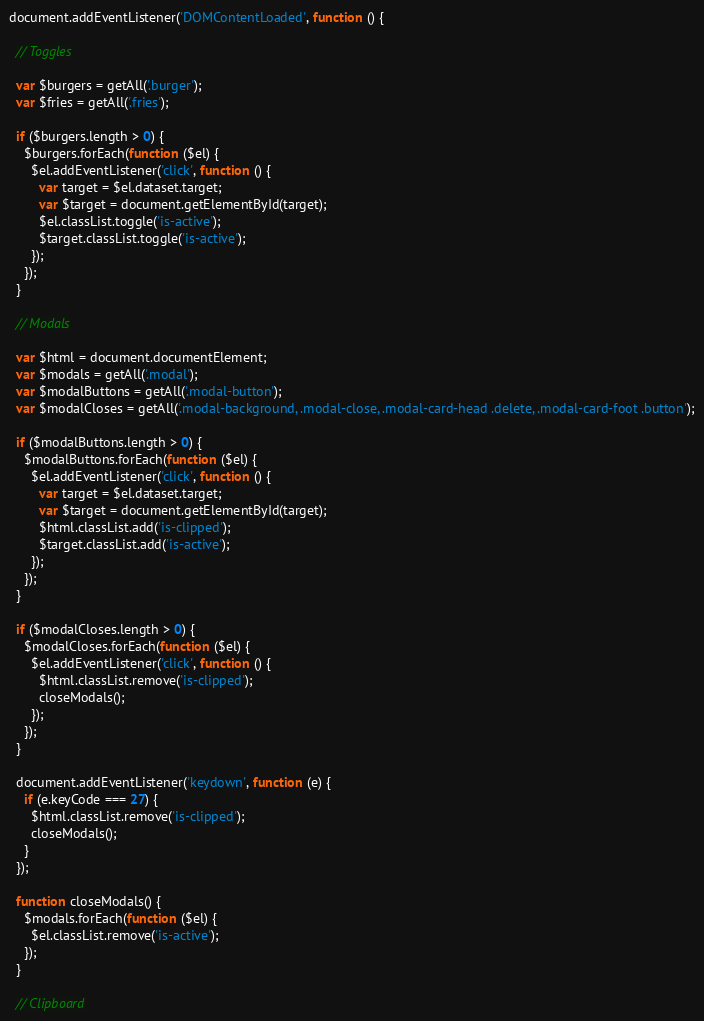<code> <loc_0><loc_0><loc_500><loc_500><_JavaScript_>
document.addEventListener('DOMContentLoaded', function () {

  // Toggles

  var $burgers = getAll('.burger');
  var $fries = getAll('.fries');

  if ($burgers.length > 0) {
    $burgers.forEach(function ($el) {
      $el.addEventListener('click', function () {
        var target = $el.dataset.target;
        var $target = document.getElementById(target);
        $el.classList.toggle('is-active');
        $target.classList.toggle('is-active');
      });
    });
  }

  // Modals

  var $html = document.documentElement;
  var $modals = getAll('.modal');
  var $modalButtons = getAll('.modal-button');
  var $modalCloses = getAll('.modal-background, .modal-close, .modal-card-head .delete, .modal-card-foot .button');

  if ($modalButtons.length > 0) {
    $modalButtons.forEach(function ($el) {
      $el.addEventListener('click', function () {
        var target = $el.dataset.target;
        var $target = document.getElementById(target);
        $html.classList.add('is-clipped');
        $target.classList.add('is-active');
      });
    });
  }

  if ($modalCloses.length > 0) {
    $modalCloses.forEach(function ($el) {
      $el.addEventListener('click', function () {
        $html.classList.remove('is-clipped');
        closeModals();
      });
    });
  }

  document.addEventListener('keydown', function (e) {
    if (e.keyCode === 27) {
      $html.classList.remove('is-clipped');
      closeModals();
    }
  });

  function closeModals() {
    $modals.forEach(function ($el) {
      $el.classList.remove('is-active');
    });
  }

  // Clipboard
</code> 